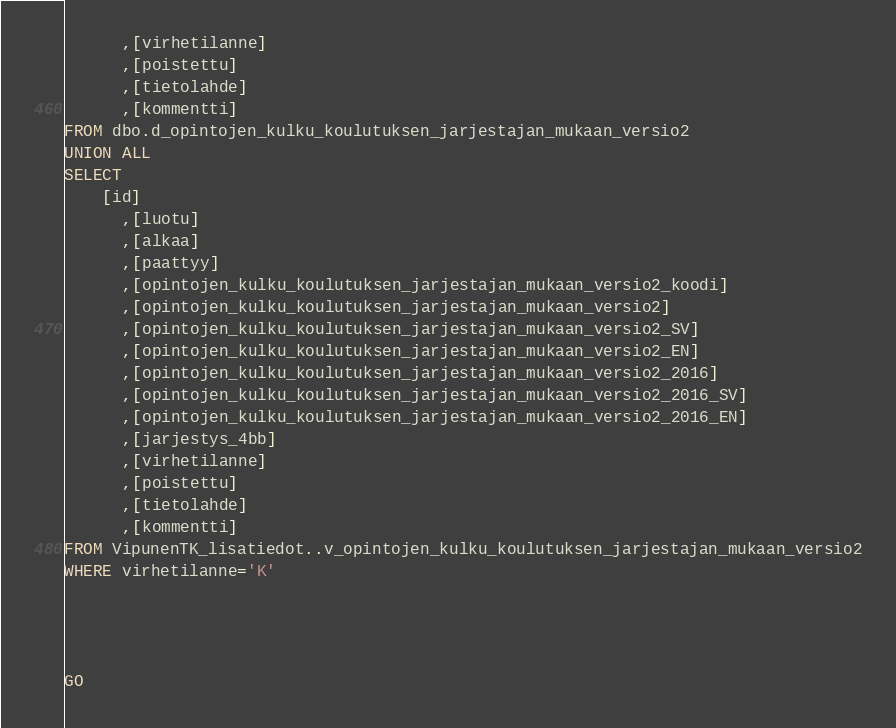Convert code to text. <code><loc_0><loc_0><loc_500><loc_500><_SQL_>      ,[virhetilanne]
      ,[poistettu]
      ,[tietolahde]
      ,[kommentti]
FROM dbo.d_opintojen_kulku_koulutuksen_jarjestajan_mukaan_versio2
UNION ALL
SELECT
	[id]
      ,[luotu]
      ,[alkaa]
      ,[paattyy]
      ,[opintojen_kulku_koulutuksen_jarjestajan_mukaan_versio2_koodi]
      ,[opintojen_kulku_koulutuksen_jarjestajan_mukaan_versio2]
      ,[opintojen_kulku_koulutuksen_jarjestajan_mukaan_versio2_SV]
      ,[opintojen_kulku_koulutuksen_jarjestajan_mukaan_versio2_EN]
      ,[opintojen_kulku_koulutuksen_jarjestajan_mukaan_versio2_2016]
      ,[opintojen_kulku_koulutuksen_jarjestajan_mukaan_versio2_2016_SV]
      ,[opintojen_kulku_koulutuksen_jarjestajan_mukaan_versio2_2016_EN]
      ,[jarjestys_4bb]
      ,[virhetilanne]
      ,[poistettu]
      ,[tietolahde]
      ,[kommentti]
FROM VipunenTK_lisatiedot..v_opintojen_kulku_koulutuksen_jarjestajan_mukaan_versio2
WHERE virhetilanne='K'




GO


</code> 